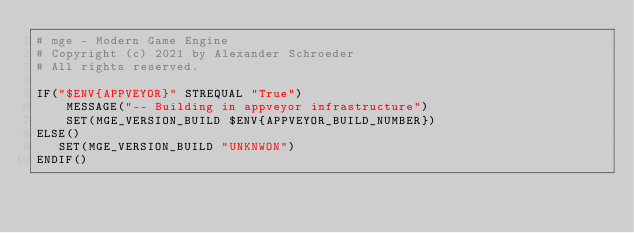Convert code to text. <code><loc_0><loc_0><loc_500><loc_500><_CMake_># mge - Modern Game Engine
# Copyright (c) 2021 by Alexander Schroeder
# All rights reserved.

IF("$ENV{APPVEYOR}" STREQUAL "True")
    MESSAGE("-- Building in appveyor infrastructure")
    SET(MGE_VERSION_BUILD $ENV{APPVEYOR_BUILD_NUMBER})
ELSE()
   SET(MGE_VERSION_BUILD "UNKNWON")
ENDIF()

</code> 